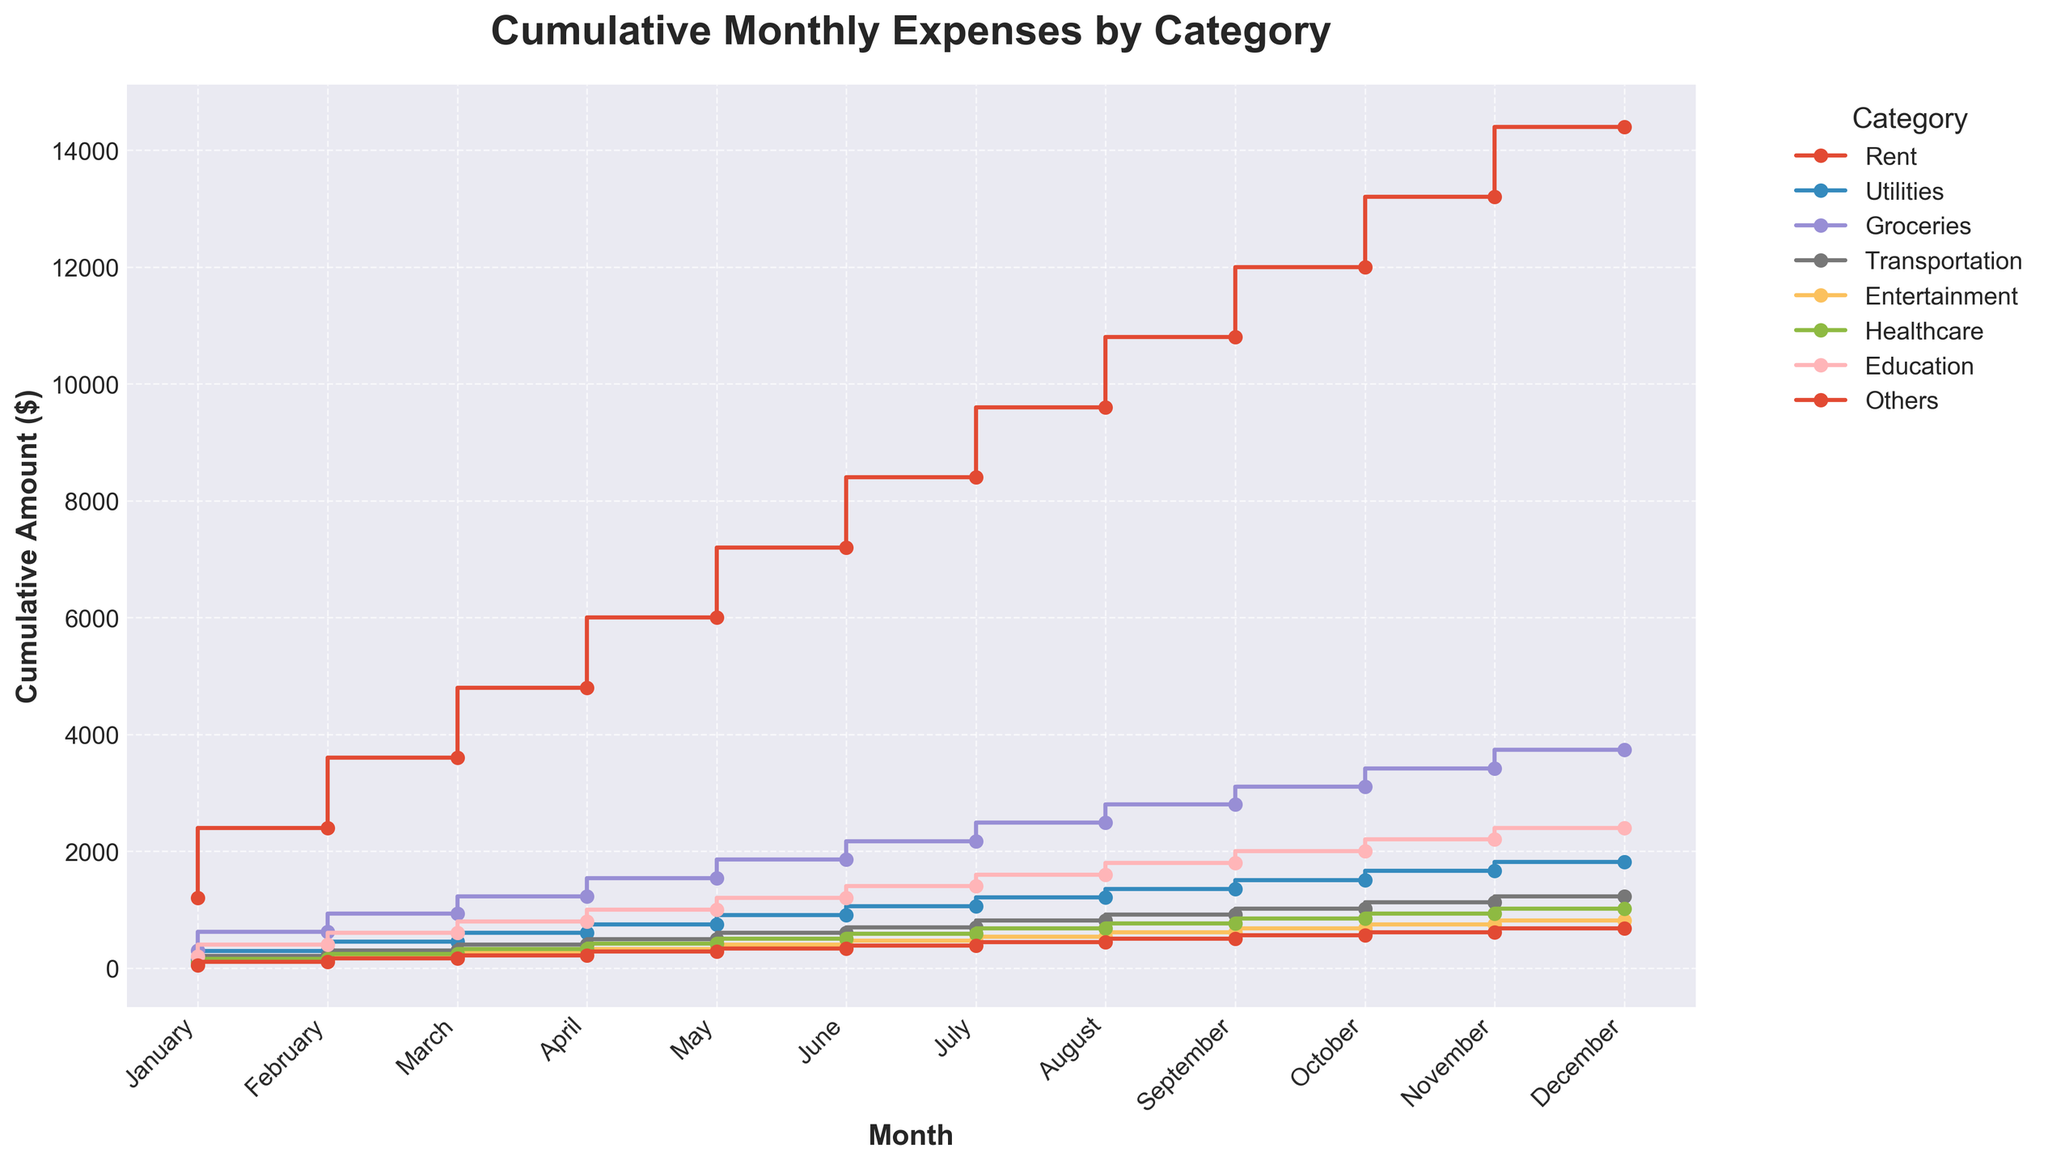What is the title of the plot? The title is located at the top of the plot and is often in a larger, bold font to distinguish it from other text.
Answer: Cumulative Monthly Expenses by Category Which month has the highest cumulative amount for Groceries? Look at the line representing Groceries and find the highest point it reaches along the vertical axis. Check the corresponding month on the horizontal axis.
Answer: December What is the cumulative amount of Healthcare in April? Locate the step plot line corresponding to Healthcare. Trace the line to April and look at its cumulative amount on the vertical axis.
Answer: 320 In which month do Education expenses reach a cumulative amount of 1,200? Follow the step plot line for Education and find the point where it intersects with the vertical axis at 1,200. Look at the corresponding month on the horizontal axis.
Answer: June Which category has the steepest increase in cumulative expenses between May and June? Compare the slopes of all category lines between May and June. The steepest slope indicates the largest increase in cumulative expenses.
Answer: Utilities What is the cumulative difference in Transportation expenses between July and September? Identify the cumulative amounts for Transportation in July and September and subtract the July amount from the September amount.
Answer: 205 - 100 = 105 What is the average cumulative amount for the Rent category in the first half of the year (January to June)? Add up the cumulative amounts for Rent from January to June and divide by 6. The cumulative amounts are: 1200 + 2400 + 3600 + 4800 + 6000 + 7200. Average: (7200 / 6)
Answer: 1200*6 / 6 = 7200 / 6 = 1200 How do the cumulative expenses for Entertainment in March compare to those in October? Locate the points on the Entertainment line for both March and October and compare their cumulative amounts.
Answer: March: 185, October: 740. October is higher Which category shows the most fluctuation in cumulative expenses over the year? Trace each category line and observe the variability in the slope or step changes. The line with the most fluctuations in the vertical direction shows the most fluctuation.
Answer: Others Do cumulative household expenses for any category remain constant throughout the year? Analyze the lines for each category to see if any line is a straight horizontal line, indicating no change in cumulative expenses.
Answer: No 